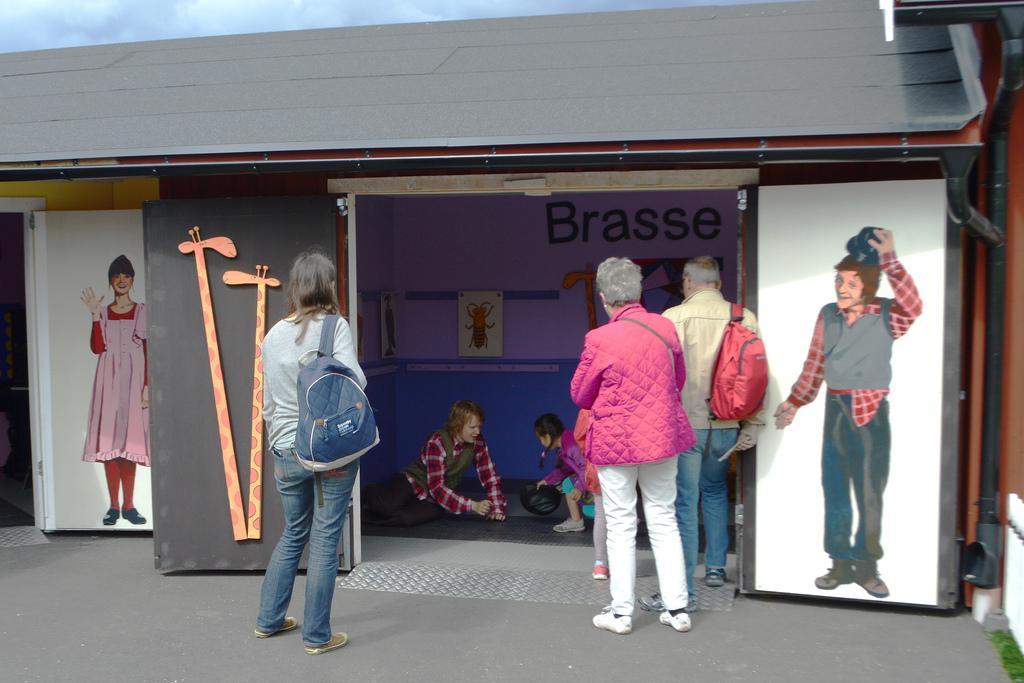In one or two sentences, can you explain what this image depicts? In this image we can see some people watching the activities of the other people who are in the stall/shed. And we can see the pictures on left and right sides. 